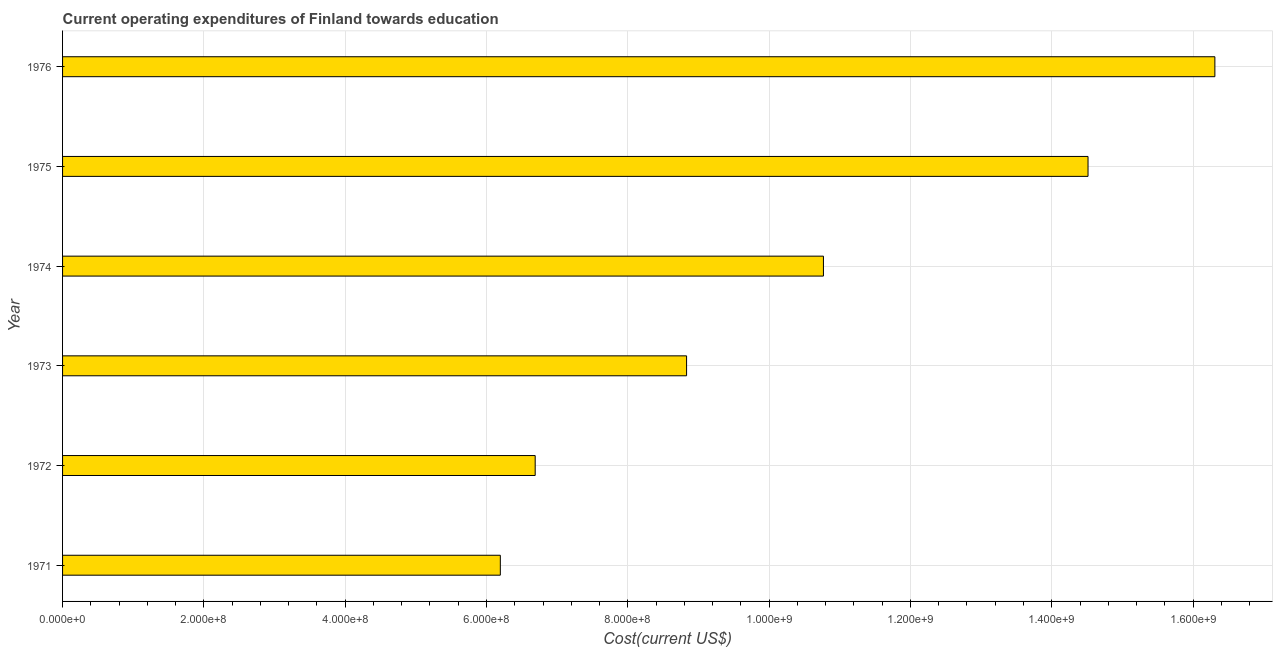Does the graph contain grids?
Provide a short and direct response. Yes. What is the title of the graph?
Give a very brief answer. Current operating expenditures of Finland towards education. What is the label or title of the X-axis?
Offer a very short reply. Cost(current US$). What is the education expenditure in 1975?
Ensure brevity in your answer.  1.45e+09. Across all years, what is the maximum education expenditure?
Ensure brevity in your answer.  1.63e+09. Across all years, what is the minimum education expenditure?
Your answer should be compact. 6.20e+08. In which year was the education expenditure maximum?
Provide a short and direct response. 1976. What is the sum of the education expenditure?
Ensure brevity in your answer.  6.33e+09. What is the difference between the education expenditure in 1971 and 1972?
Keep it short and to the point. -4.93e+07. What is the average education expenditure per year?
Provide a short and direct response. 1.06e+09. What is the median education expenditure?
Give a very brief answer. 9.80e+08. What is the ratio of the education expenditure in 1972 to that in 1975?
Give a very brief answer. 0.46. Is the difference between the education expenditure in 1974 and 1976 greater than the difference between any two years?
Make the answer very short. No. What is the difference between the highest and the second highest education expenditure?
Ensure brevity in your answer.  1.80e+08. What is the difference between the highest and the lowest education expenditure?
Offer a very short reply. 1.01e+09. Are all the bars in the graph horizontal?
Make the answer very short. Yes. Are the values on the major ticks of X-axis written in scientific E-notation?
Make the answer very short. Yes. What is the Cost(current US$) of 1971?
Keep it short and to the point. 6.20e+08. What is the Cost(current US$) of 1972?
Your answer should be compact. 6.69e+08. What is the Cost(current US$) of 1973?
Your answer should be compact. 8.83e+08. What is the Cost(current US$) in 1974?
Your answer should be very brief. 1.08e+09. What is the Cost(current US$) in 1975?
Your answer should be compact. 1.45e+09. What is the Cost(current US$) in 1976?
Make the answer very short. 1.63e+09. What is the difference between the Cost(current US$) in 1971 and 1972?
Give a very brief answer. -4.93e+07. What is the difference between the Cost(current US$) in 1971 and 1973?
Your answer should be very brief. -2.64e+08. What is the difference between the Cost(current US$) in 1971 and 1974?
Give a very brief answer. -4.57e+08. What is the difference between the Cost(current US$) in 1971 and 1975?
Make the answer very short. -8.32e+08. What is the difference between the Cost(current US$) in 1971 and 1976?
Your answer should be compact. -1.01e+09. What is the difference between the Cost(current US$) in 1972 and 1973?
Give a very brief answer. -2.14e+08. What is the difference between the Cost(current US$) in 1972 and 1974?
Offer a very short reply. -4.08e+08. What is the difference between the Cost(current US$) in 1972 and 1975?
Keep it short and to the point. -7.82e+08. What is the difference between the Cost(current US$) in 1972 and 1976?
Your response must be concise. -9.62e+08. What is the difference between the Cost(current US$) in 1973 and 1974?
Give a very brief answer. -1.94e+08. What is the difference between the Cost(current US$) in 1973 and 1975?
Offer a terse response. -5.68e+08. What is the difference between the Cost(current US$) in 1973 and 1976?
Offer a terse response. -7.48e+08. What is the difference between the Cost(current US$) in 1974 and 1975?
Your response must be concise. -3.74e+08. What is the difference between the Cost(current US$) in 1974 and 1976?
Provide a succinct answer. -5.54e+08. What is the difference between the Cost(current US$) in 1975 and 1976?
Make the answer very short. -1.80e+08. What is the ratio of the Cost(current US$) in 1971 to that in 1972?
Offer a terse response. 0.93. What is the ratio of the Cost(current US$) in 1971 to that in 1973?
Make the answer very short. 0.7. What is the ratio of the Cost(current US$) in 1971 to that in 1974?
Provide a short and direct response. 0.57. What is the ratio of the Cost(current US$) in 1971 to that in 1975?
Provide a short and direct response. 0.43. What is the ratio of the Cost(current US$) in 1971 to that in 1976?
Provide a succinct answer. 0.38. What is the ratio of the Cost(current US$) in 1972 to that in 1973?
Make the answer very short. 0.76. What is the ratio of the Cost(current US$) in 1972 to that in 1974?
Your answer should be very brief. 0.62. What is the ratio of the Cost(current US$) in 1972 to that in 1975?
Offer a terse response. 0.46. What is the ratio of the Cost(current US$) in 1972 to that in 1976?
Keep it short and to the point. 0.41. What is the ratio of the Cost(current US$) in 1973 to that in 1974?
Provide a short and direct response. 0.82. What is the ratio of the Cost(current US$) in 1973 to that in 1975?
Provide a succinct answer. 0.61. What is the ratio of the Cost(current US$) in 1973 to that in 1976?
Make the answer very short. 0.54. What is the ratio of the Cost(current US$) in 1974 to that in 1975?
Offer a terse response. 0.74. What is the ratio of the Cost(current US$) in 1974 to that in 1976?
Provide a succinct answer. 0.66. What is the ratio of the Cost(current US$) in 1975 to that in 1976?
Provide a short and direct response. 0.89. 